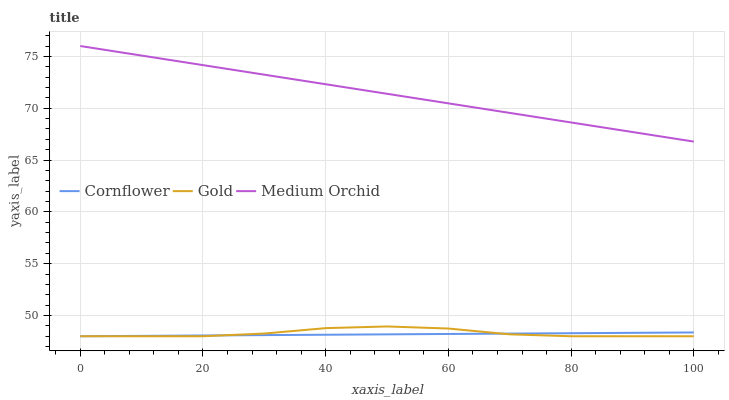Does Cornflower have the minimum area under the curve?
Answer yes or no. Yes. Does Medium Orchid have the maximum area under the curve?
Answer yes or no. Yes. Does Gold have the minimum area under the curve?
Answer yes or no. No. Does Gold have the maximum area under the curve?
Answer yes or no. No. Is Medium Orchid the smoothest?
Answer yes or no. Yes. Is Gold the roughest?
Answer yes or no. Yes. Is Gold the smoothest?
Answer yes or no. No. Is Medium Orchid the roughest?
Answer yes or no. No. Does Medium Orchid have the lowest value?
Answer yes or no. No. Does Gold have the highest value?
Answer yes or no. No. Is Gold less than Medium Orchid?
Answer yes or no. Yes. Is Medium Orchid greater than Cornflower?
Answer yes or no. Yes. Does Gold intersect Medium Orchid?
Answer yes or no. No. 